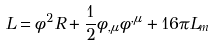<formula> <loc_0><loc_0><loc_500><loc_500>L = \phi ^ { 2 } R + \frac { 1 } { 2 } \phi _ { , \mu } \phi ^ { , \mu } + 1 6 \pi L _ { m }</formula> 